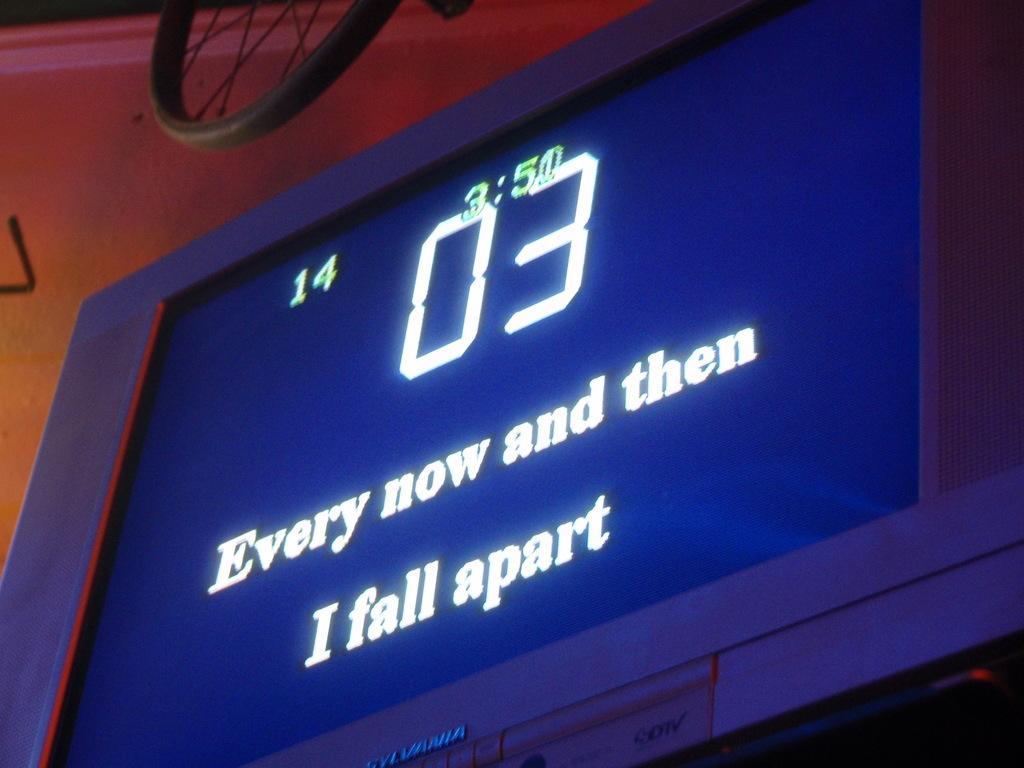<image>
Share a concise interpretation of the image provided. A Sylvania TV showing song lyrics "Every now and then I fall apart" 